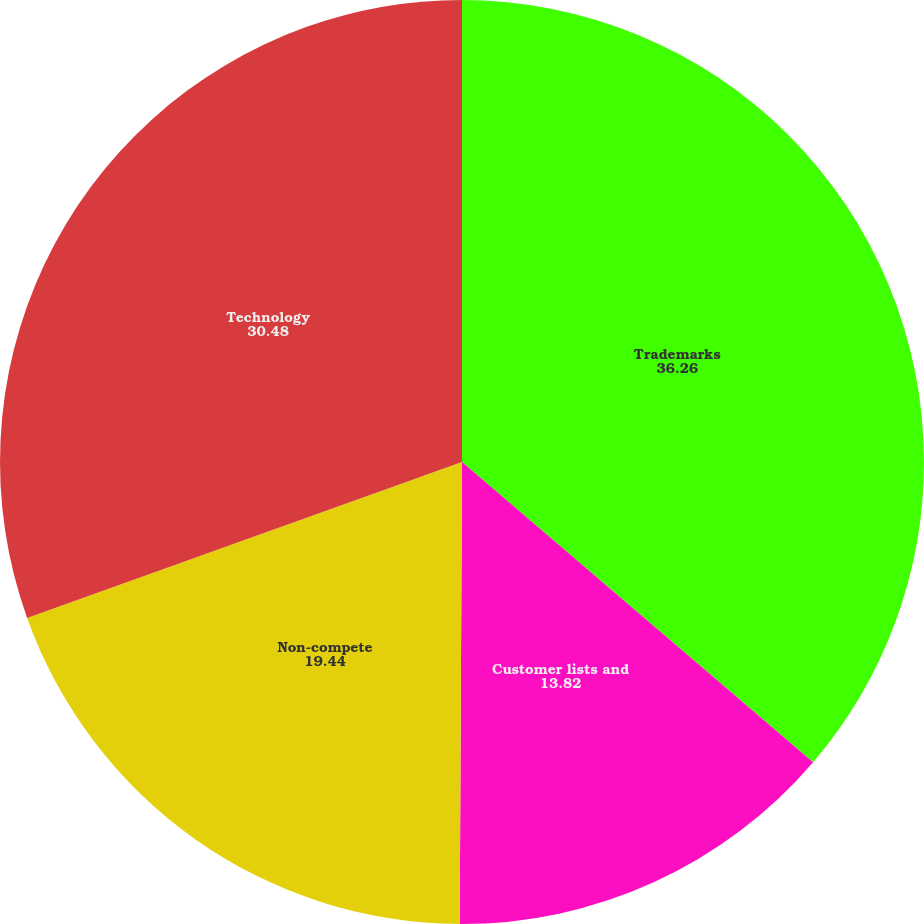Convert chart to OTSL. <chart><loc_0><loc_0><loc_500><loc_500><pie_chart><fcel>Trademarks<fcel>Customer lists and<fcel>Non-compete<fcel>Technology<nl><fcel>36.26%<fcel>13.82%<fcel>19.44%<fcel>30.48%<nl></chart> 